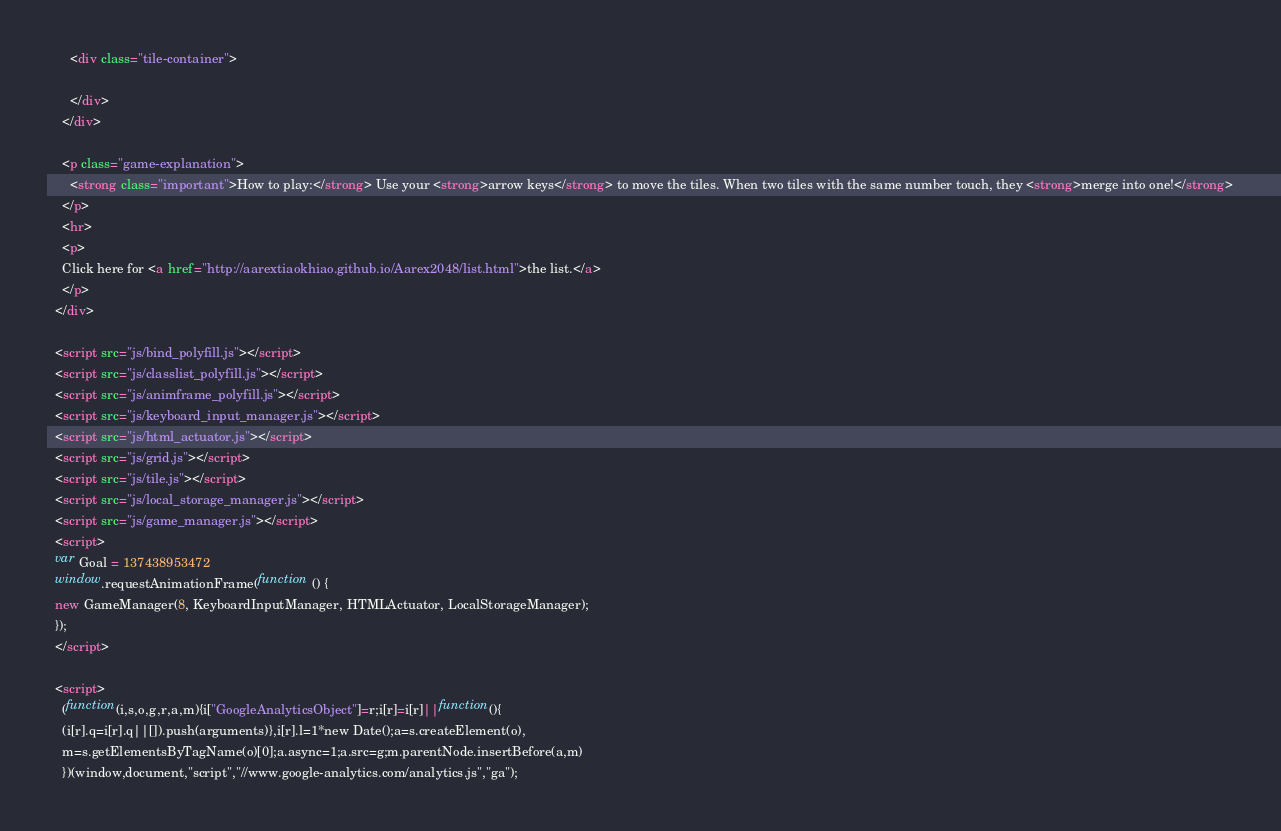Convert code to text. <code><loc_0><loc_0><loc_500><loc_500><_HTML_>      <div class="tile-container">

      </div>
    </div>

    <p class="game-explanation">
      <strong class="important">How to play:</strong> Use your <strong>arrow keys</strong> to move the tiles. When two tiles with the same number touch, they <strong>merge into one!</strong>
    </p>
    <hr>
    <p>
    Click here for <a href="http://aarextiaokhiao.github.io/Aarex2048/list.html">the list.</a>
    </p>
  </div>

  <script src="js/bind_polyfill.js"></script>
  <script src="js/classlist_polyfill.js"></script>
  <script src="js/animframe_polyfill.js"></script>
  <script src="js/keyboard_input_manager.js"></script>
  <script src="js/html_actuator.js"></script>
  <script src="js/grid.js"></script>
  <script src="js/tile.js"></script>
  <script src="js/local_storage_manager.js"></script>
  <script src="js/game_manager.js"></script>
  <script>
  var Goal = 137438953472
  window.requestAnimationFrame(function () {
  new GameManager(8, KeyboardInputManager, HTMLActuator, LocalStorageManager);
  });
  </script>

  <script>
    (function(i,s,o,g,r,a,m){i["GoogleAnalyticsObject"]=r;i[r]=i[r]||function(){
    (i[r].q=i[r].q||[]).push(arguments)},i[r].l=1*new Date();a=s.createElement(o),
    m=s.getElementsByTagName(o)[0];a.async=1;a.src=g;m.parentNode.insertBefore(a,m)
    })(window,document,"script","//www.google-analytics.com/analytics.js","ga");
</code> 